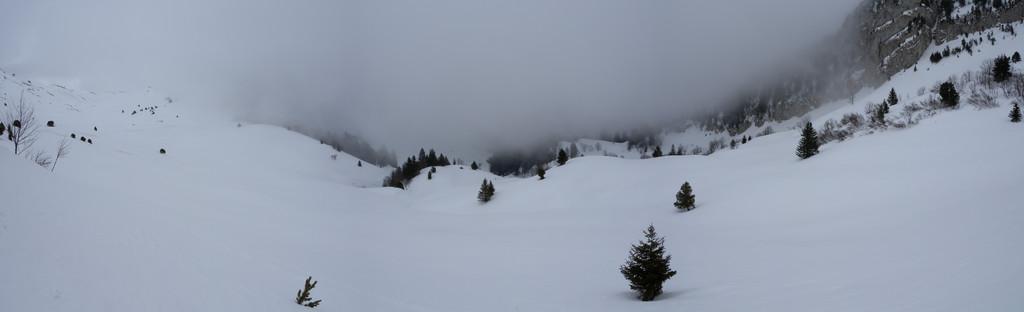Describe this image in one or two sentences. In this image we can see mountains and many trees. There is a snow in the image. 